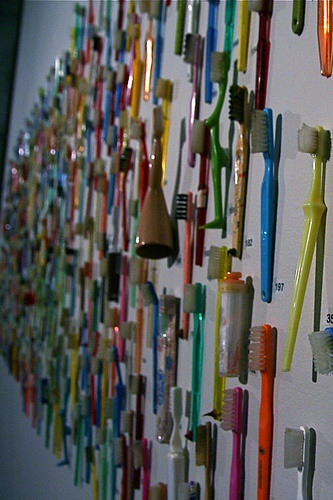Describe the objects in this image and their specific colors. I can see toothbrush in black, gray, darkgray, and olive tones, toothbrush in black, olive, and darkgray tones, toothbrush in black, maroon, and gray tones, toothbrush in black, blue, darkblue, and darkgray tones, and toothbrush in black, olive, and gray tones in this image. 